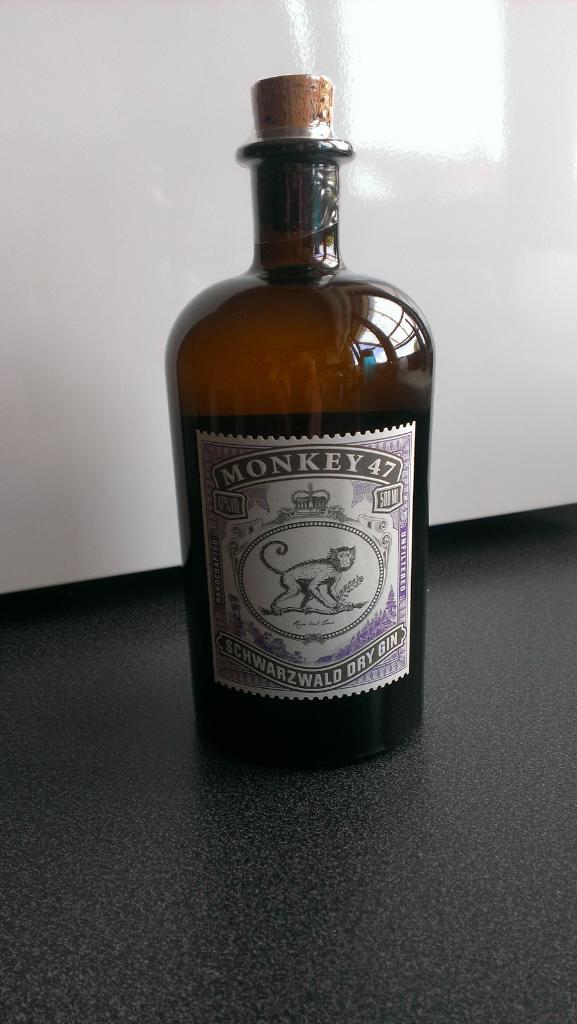How much does that bottle hold?
Your answer should be very brief. 500 ml. 